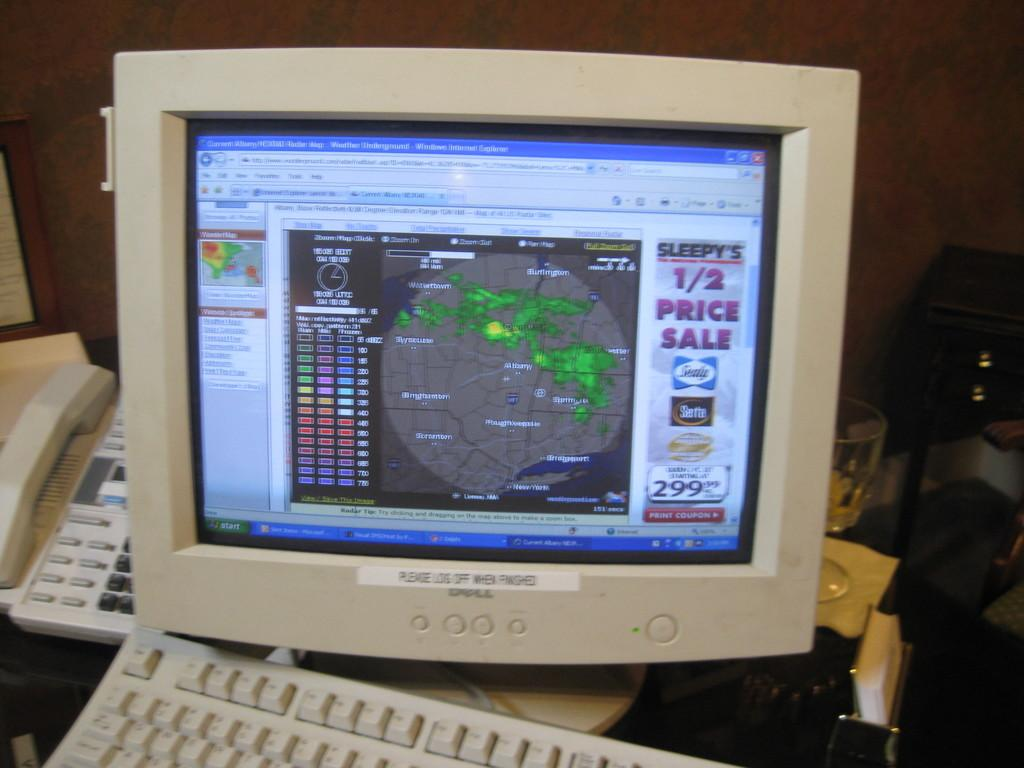<image>
Present a compact description of the photo's key features. Sleepy's is having a half price sale if you print the coupon. 